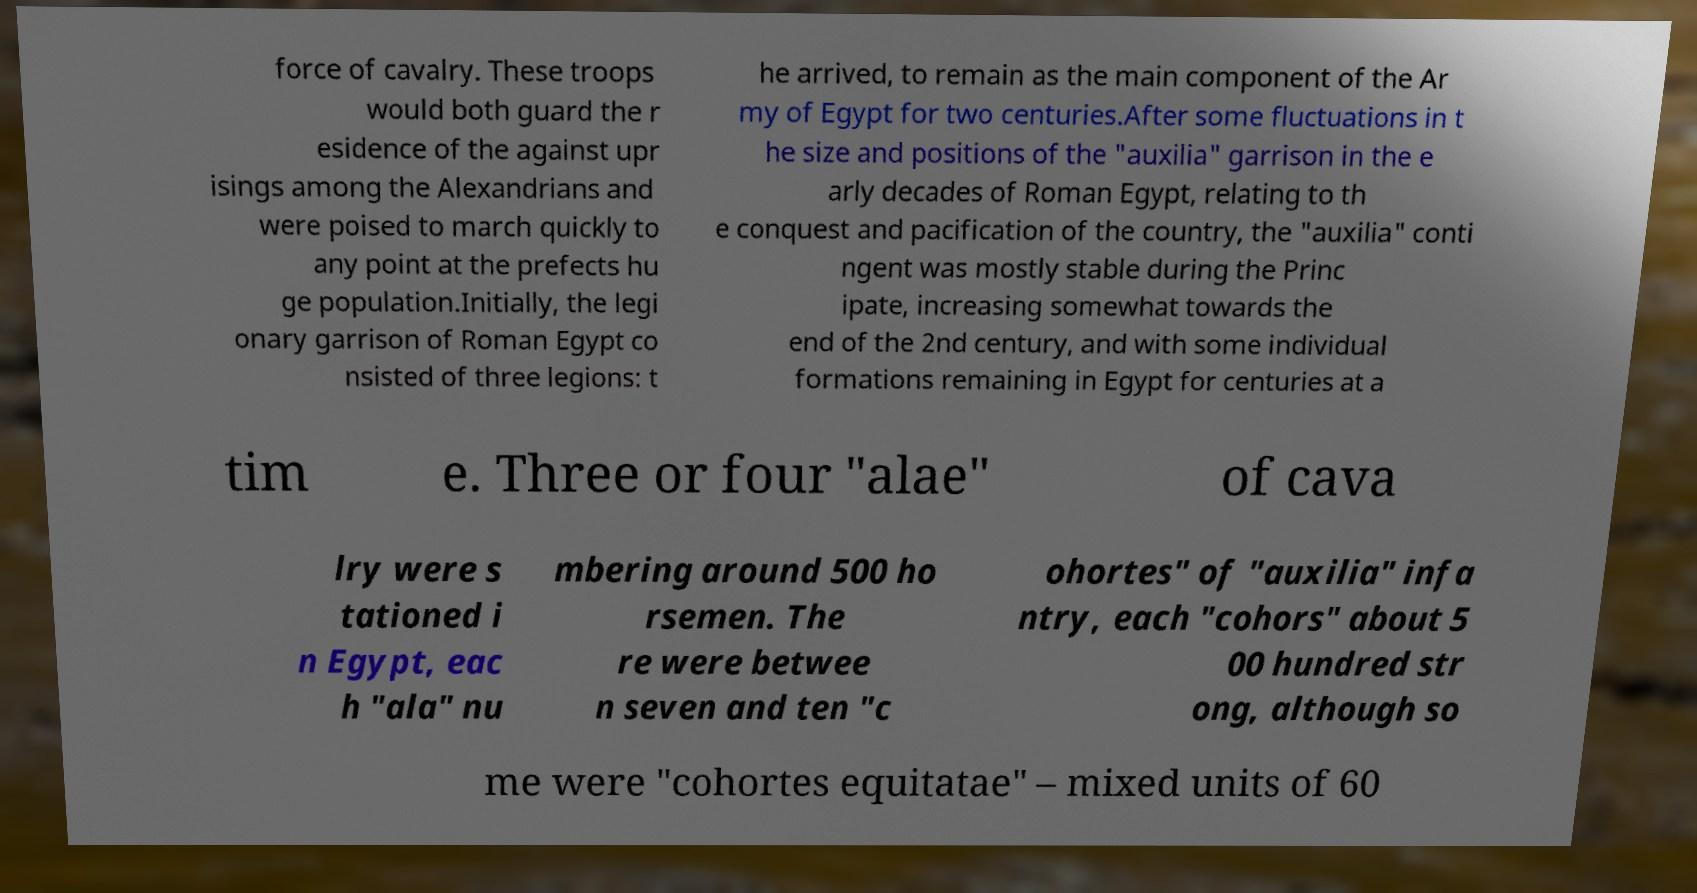What messages or text are displayed in this image? I need them in a readable, typed format. force of cavalry. These troops would both guard the r esidence of the against upr isings among the Alexandrians and were poised to march quickly to any point at the prefects hu ge population.Initially, the legi onary garrison of Roman Egypt co nsisted of three legions: t he arrived, to remain as the main component of the Ar my of Egypt for two centuries.After some fluctuations in t he size and positions of the "auxilia" garrison in the e arly decades of Roman Egypt, relating to th e conquest and pacification of the country, the "auxilia" conti ngent was mostly stable during the Princ ipate, increasing somewhat towards the end of the 2nd century, and with some individual formations remaining in Egypt for centuries at a tim e. Three or four "alae" of cava lry were s tationed i n Egypt, eac h "ala" nu mbering around 500 ho rsemen. The re were betwee n seven and ten "c ohortes" of "auxilia" infa ntry, each "cohors" about 5 00 hundred str ong, although so me were "cohortes equitatae" – mixed units of 60 